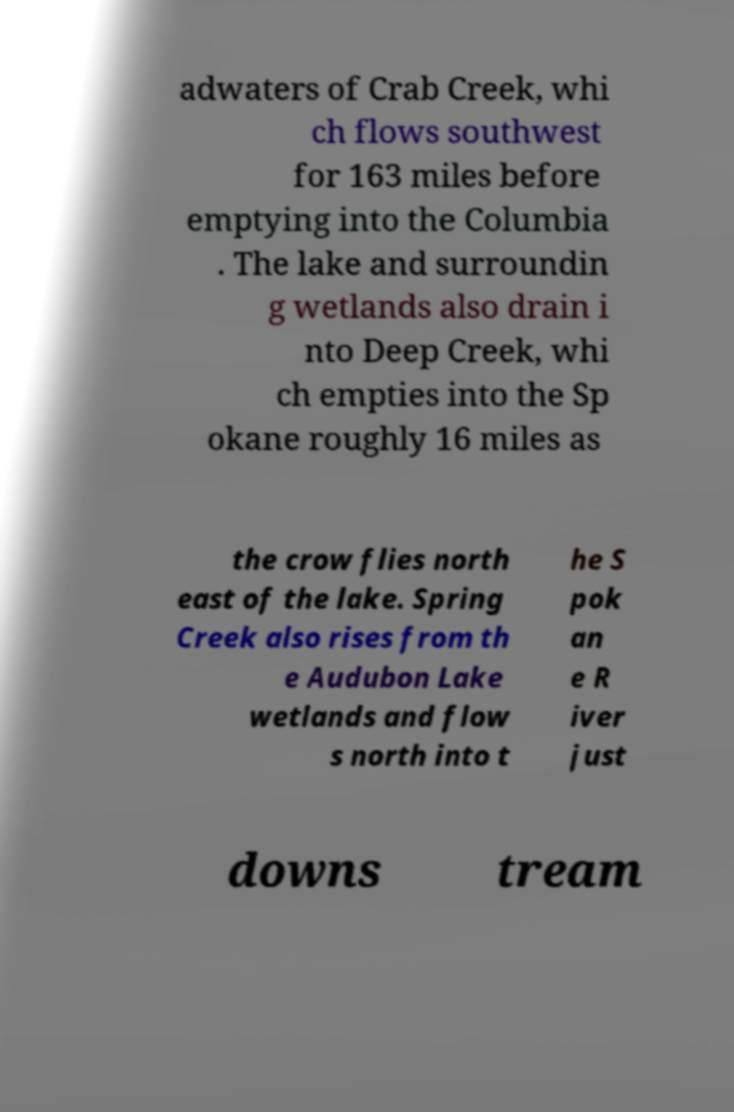Can you accurately transcribe the text from the provided image for me? adwaters of Crab Creek, whi ch flows southwest for 163 miles before emptying into the Columbia . The lake and surroundin g wetlands also drain i nto Deep Creek, whi ch empties into the Sp okane roughly 16 miles as the crow flies north east of the lake. Spring Creek also rises from th e Audubon Lake wetlands and flow s north into t he S pok an e R iver just downs tream 